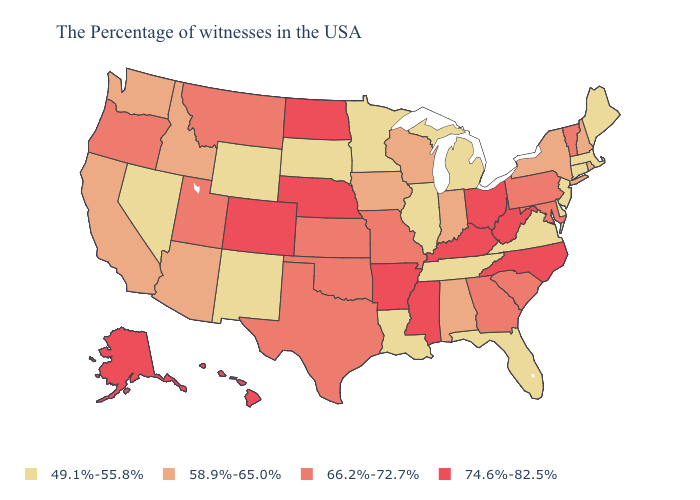Name the states that have a value in the range 58.9%-65.0%?
Quick response, please. Rhode Island, New Hampshire, New York, Indiana, Alabama, Wisconsin, Iowa, Arizona, Idaho, California, Washington. Among the states that border Utah , which have the highest value?
Concise answer only. Colorado. Does Pennsylvania have the same value as Indiana?
Short answer required. No. Name the states that have a value in the range 74.6%-82.5%?
Give a very brief answer. North Carolina, West Virginia, Ohio, Kentucky, Mississippi, Arkansas, Nebraska, North Dakota, Colorado, Alaska, Hawaii. Which states have the lowest value in the USA?
Give a very brief answer. Maine, Massachusetts, Connecticut, New Jersey, Delaware, Virginia, Florida, Michigan, Tennessee, Illinois, Louisiana, Minnesota, South Dakota, Wyoming, New Mexico, Nevada. What is the value of Illinois?
Concise answer only. 49.1%-55.8%. Which states have the lowest value in the West?
Write a very short answer. Wyoming, New Mexico, Nevada. What is the lowest value in states that border Vermont?
Keep it brief. 49.1%-55.8%. Name the states that have a value in the range 66.2%-72.7%?
Give a very brief answer. Vermont, Maryland, Pennsylvania, South Carolina, Georgia, Missouri, Kansas, Oklahoma, Texas, Utah, Montana, Oregon. Name the states that have a value in the range 49.1%-55.8%?
Short answer required. Maine, Massachusetts, Connecticut, New Jersey, Delaware, Virginia, Florida, Michigan, Tennessee, Illinois, Louisiana, Minnesota, South Dakota, Wyoming, New Mexico, Nevada. Does Nevada have the lowest value in the West?
Quick response, please. Yes. Among the states that border Montana , which have the highest value?
Quick response, please. North Dakota. What is the lowest value in states that border Oregon?
Short answer required. 49.1%-55.8%. What is the lowest value in states that border Florida?
Be succinct. 58.9%-65.0%. 